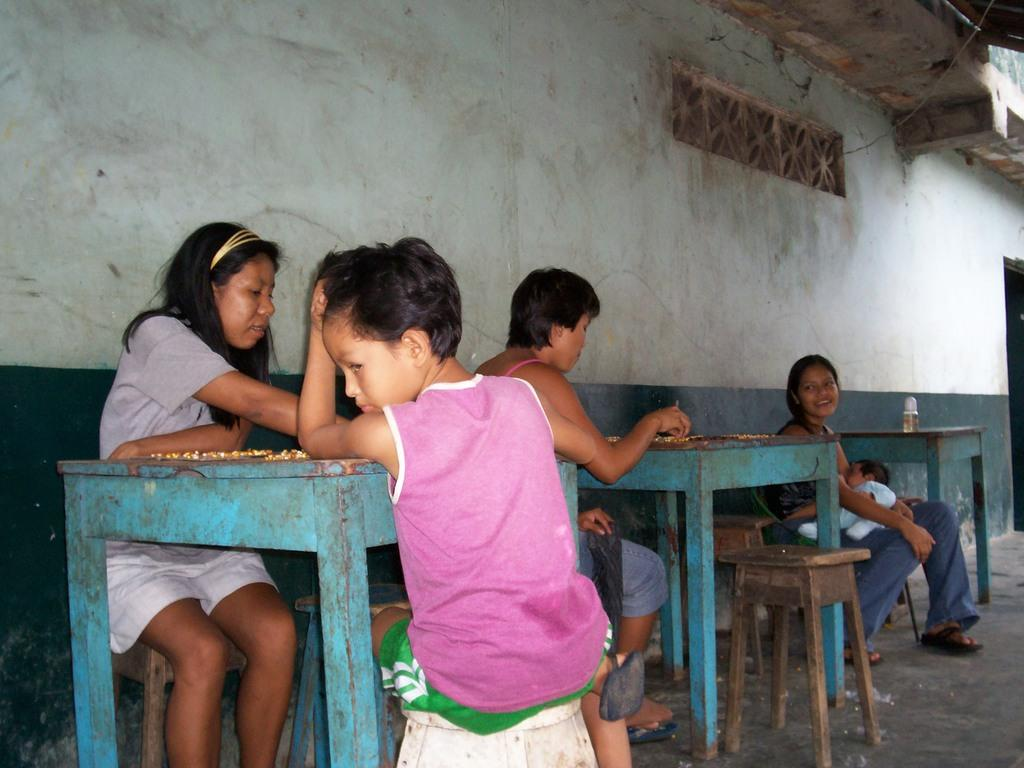What are the people in the image doing? The people in the image are sitting at tables. How are the tables arranged in the image? The tables are arranged in a row. Can you see a snail crawling on the table in the image? There is no snail present in the image. What force is causing the tables to move in the image? There is no force causing the tables to move in the image; they are stationary. 